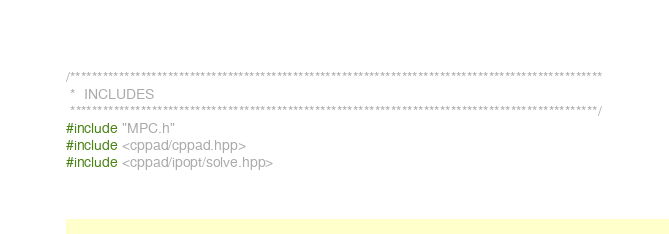<code> <loc_0><loc_0><loc_500><loc_500><_C++_>/**************************************************************************************************
 *  INCLUDES
 *************************************************************************************************/
#include "MPC.h"
#include <cppad/cppad.hpp>
#include <cppad/ipopt/solve.hpp></code> 